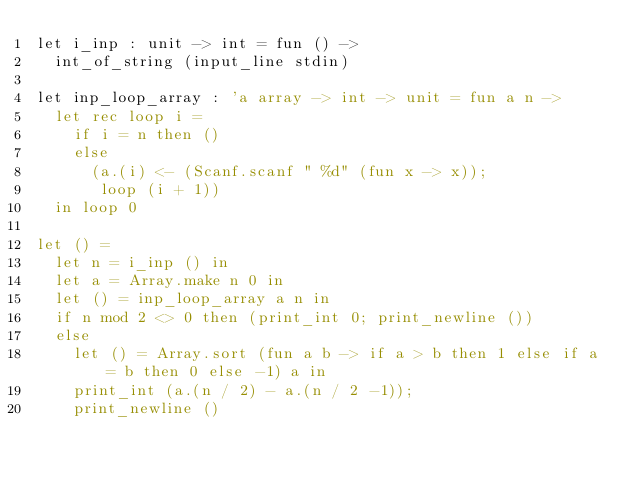Convert code to text. <code><loc_0><loc_0><loc_500><loc_500><_OCaml_>let i_inp : unit -> int = fun () ->
  int_of_string (input_line stdin)

let inp_loop_array : 'a array -> int -> unit = fun a n ->
  let rec loop i = 
    if i = n then ()
    else
      (a.(i) <- (Scanf.scanf " %d" (fun x -> x));
       loop (i + 1))
  in loop 0 
   
let () =
  let n = i_inp () in
  let a = Array.make n 0 in
  let () = inp_loop_array a n in
  if n mod 2 <> 0 then (print_int 0; print_newline ())
  else
    let () = Array.sort (fun a b -> if a > b then 1 else if a = b then 0 else -1) a in 
    print_int (a.(n / 2) - a.(n / 2 -1));
    print_newline ()
      
        
</code> 